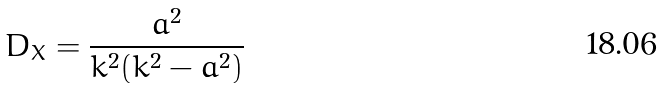Convert formula to latex. <formula><loc_0><loc_0><loc_500><loc_500>D _ { X } = \frac { a ^ { 2 } } { k ^ { 2 } ( k ^ { 2 } - a ^ { 2 } ) }</formula> 